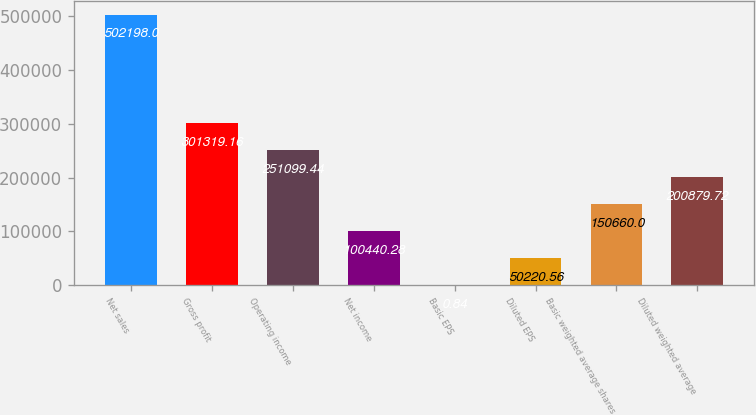Convert chart to OTSL. <chart><loc_0><loc_0><loc_500><loc_500><bar_chart><fcel>Net sales<fcel>Gross profit<fcel>Operating income<fcel>Net income<fcel>Basic EPS<fcel>Diluted EPS<fcel>Basic weighted average shares<fcel>Diluted weighted average<nl><fcel>502198<fcel>301319<fcel>251099<fcel>100440<fcel>0.84<fcel>50220.6<fcel>150660<fcel>200880<nl></chart> 